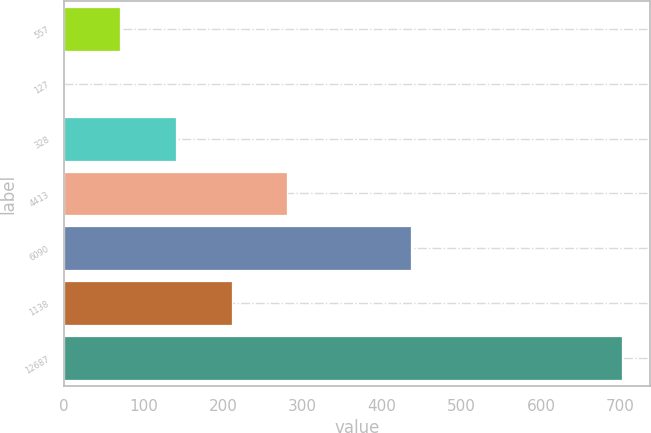Convert chart. <chart><loc_0><loc_0><loc_500><loc_500><bar_chart><fcel>557<fcel>127<fcel>328<fcel>4413<fcel>6090<fcel>1138<fcel>12687<nl><fcel>70.31<fcel>0.1<fcel>140.52<fcel>280.94<fcel>435.8<fcel>210.73<fcel>702.2<nl></chart> 